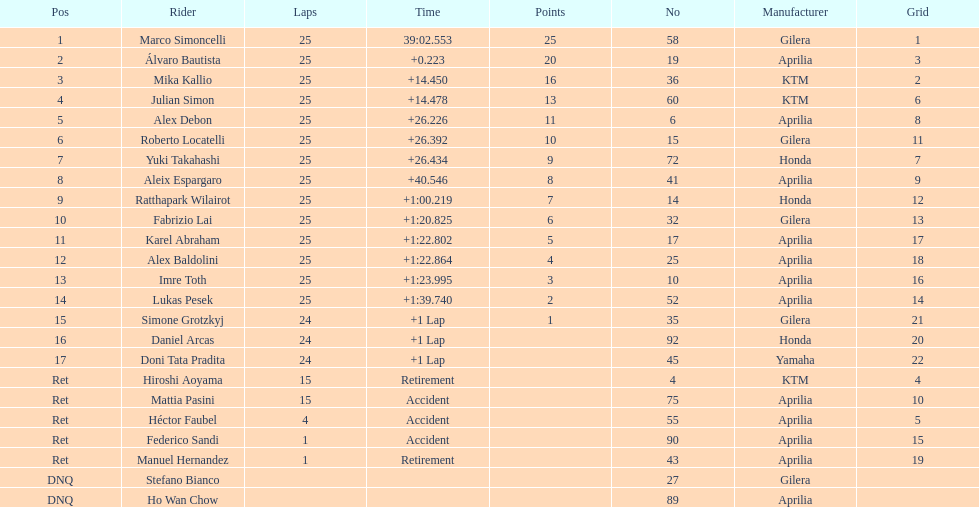How many riders manufacturer is honda? 3. 